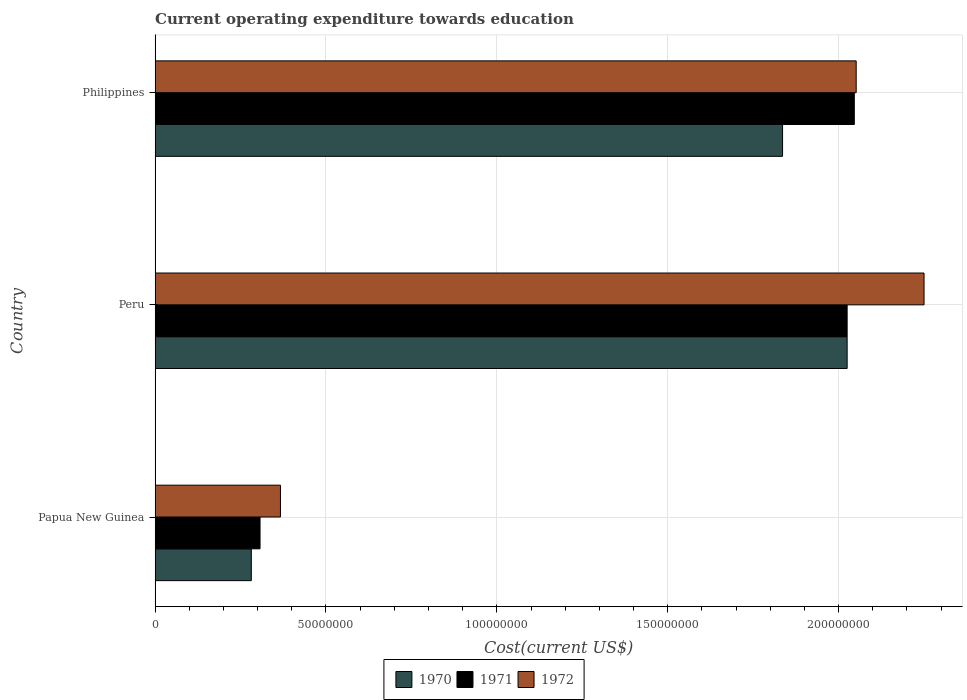How many different coloured bars are there?
Keep it short and to the point. 3. Are the number of bars per tick equal to the number of legend labels?
Provide a succinct answer. Yes. Are the number of bars on each tick of the Y-axis equal?
Your response must be concise. Yes. How many bars are there on the 2nd tick from the top?
Give a very brief answer. 3. What is the label of the 3rd group of bars from the top?
Your answer should be compact. Papua New Guinea. What is the expenditure towards education in 1971 in Peru?
Provide a short and direct response. 2.02e+08. Across all countries, what is the maximum expenditure towards education in 1970?
Ensure brevity in your answer.  2.02e+08. Across all countries, what is the minimum expenditure towards education in 1972?
Your answer should be compact. 3.67e+07. In which country was the expenditure towards education in 1971 maximum?
Your answer should be very brief. Philippines. In which country was the expenditure towards education in 1970 minimum?
Offer a very short reply. Papua New Guinea. What is the total expenditure towards education in 1972 in the graph?
Your answer should be very brief. 4.67e+08. What is the difference between the expenditure towards education in 1971 in Peru and that in Philippines?
Provide a short and direct response. -2.10e+06. What is the difference between the expenditure towards education in 1972 in Peru and the expenditure towards education in 1971 in Philippines?
Provide a succinct answer. 2.04e+07. What is the average expenditure towards education in 1972 per country?
Keep it short and to the point. 1.56e+08. What is the difference between the expenditure towards education in 1972 and expenditure towards education in 1971 in Papua New Guinea?
Your answer should be very brief. 5.97e+06. In how many countries, is the expenditure towards education in 1971 greater than 70000000 US$?
Keep it short and to the point. 2. What is the ratio of the expenditure towards education in 1970 in Papua New Guinea to that in Peru?
Provide a succinct answer. 0.14. Is the difference between the expenditure towards education in 1972 in Peru and Philippines greater than the difference between the expenditure towards education in 1971 in Peru and Philippines?
Your answer should be very brief. Yes. What is the difference between the highest and the second highest expenditure towards education in 1971?
Provide a succinct answer. 2.10e+06. What is the difference between the highest and the lowest expenditure towards education in 1970?
Provide a succinct answer. 1.74e+08. How many countries are there in the graph?
Offer a very short reply. 3. What is the difference between two consecutive major ticks on the X-axis?
Offer a terse response. 5.00e+07. Does the graph contain any zero values?
Make the answer very short. No. Does the graph contain grids?
Provide a succinct answer. Yes. Where does the legend appear in the graph?
Keep it short and to the point. Bottom center. What is the title of the graph?
Your answer should be compact. Current operating expenditure towards education. What is the label or title of the X-axis?
Keep it short and to the point. Cost(current US$). What is the label or title of the Y-axis?
Provide a succinct answer. Country. What is the Cost(current US$) of 1970 in Papua New Guinea?
Your answer should be very brief. 2.82e+07. What is the Cost(current US$) of 1971 in Papua New Guinea?
Provide a short and direct response. 3.07e+07. What is the Cost(current US$) of 1972 in Papua New Guinea?
Give a very brief answer. 3.67e+07. What is the Cost(current US$) in 1970 in Peru?
Keep it short and to the point. 2.02e+08. What is the Cost(current US$) in 1971 in Peru?
Your response must be concise. 2.02e+08. What is the Cost(current US$) in 1972 in Peru?
Provide a succinct answer. 2.25e+08. What is the Cost(current US$) of 1970 in Philippines?
Offer a terse response. 1.84e+08. What is the Cost(current US$) in 1971 in Philippines?
Make the answer very short. 2.05e+08. What is the Cost(current US$) in 1972 in Philippines?
Your answer should be compact. 2.05e+08. Across all countries, what is the maximum Cost(current US$) in 1970?
Give a very brief answer. 2.02e+08. Across all countries, what is the maximum Cost(current US$) of 1971?
Your answer should be compact. 2.05e+08. Across all countries, what is the maximum Cost(current US$) of 1972?
Keep it short and to the point. 2.25e+08. Across all countries, what is the minimum Cost(current US$) of 1970?
Make the answer very short. 2.82e+07. Across all countries, what is the minimum Cost(current US$) in 1971?
Keep it short and to the point. 3.07e+07. Across all countries, what is the minimum Cost(current US$) in 1972?
Provide a succinct answer. 3.67e+07. What is the total Cost(current US$) of 1970 in the graph?
Provide a short and direct response. 4.14e+08. What is the total Cost(current US$) in 1971 in the graph?
Provide a short and direct response. 4.38e+08. What is the total Cost(current US$) of 1972 in the graph?
Offer a terse response. 4.67e+08. What is the difference between the Cost(current US$) of 1970 in Papua New Guinea and that in Peru?
Ensure brevity in your answer.  -1.74e+08. What is the difference between the Cost(current US$) in 1971 in Papua New Guinea and that in Peru?
Keep it short and to the point. -1.72e+08. What is the difference between the Cost(current US$) of 1972 in Papua New Guinea and that in Peru?
Provide a succinct answer. -1.88e+08. What is the difference between the Cost(current US$) in 1970 in Papua New Guinea and that in Philippines?
Keep it short and to the point. -1.55e+08. What is the difference between the Cost(current US$) in 1971 in Papua New Guinea and that in Philippines?
Make the answer very short. -1.74e+08. What is the difference between the Cost(current US$) in 1972 in Papua New Guinea and that in Philippines?
Offer a very short reply. -1.68e+08. What is the difference between the Cost(current US$) of 1970 in Peru and that in Philippines?
Keep it short and to the point. 1.89e+07. What is the difference between the Cost(current US$) in 1971 in Peru and that in Philippines?
Your answer should be compact. -2.10e+06. What is the difference between the Cost(current US$) in 1972 in Peru and that in Philippines?
Provide a succinct answer. 1.99e+07. What is the difference between the Cost(current US$) in 1970 in Papua New Guinea and the Cost(current US$) in 1971 in Peru?
Offer a terse response. -1.74e+08. What is the difference between the Cost(current US$) of 1970 in Papua New Guinea and the Cost(current US$) of 1972 in Peru?
Make the answer very short. -1.97e+08. What is the difference between the Cost(current US$) in 1971 in Papua New Guinea and the Cost(current US$) in 1972 in Peru?
Your answer should be compact. -1.94e+08. What is the difference between the Cost(current US$) in 1970 in Papua New Guinea and the Cost(current US$) in 1971 in Philippines?
Provide a short and direct response. -1.76e+08. What is the difference between the Cost(current US$) in 1970 in Papua New Guinea and the Cost(current US$) in 1972 in Philippines?
Give a very brief answer. -1.77e+08. What is the difference between the Cost(current US$) of 1971 in Papua New Guinea and the Cost(current US$) of 1972 in Philippines?
Keep it short and to the point. -1.74e+08. What is the difference between the Cost(current US$) in 1970 in Peru and the Cost(current US$) in 1971 in Philippines?
Your answer should be very brief. -2.10e+06. What is the difference between the Cost(current US$) in 1970 in Peru and the Cost(current US$) in 1972 in Philippines?
Offer a terse response. -2.64e+06. What is the difference between the Cost(current US$) in 1971 in Peru and the Cost(current US$) in 1972 in Philippines?
Your answer should be very brief. -2.64e+06. What is the average Cost(current US$) of 1970 per country?
Provide a short and direct response. 1.38e+08. What is the average Cost(current US$) of 1971 per country?
Provide a succinct answer. 1.46e+08. What is the average Cost(current US$) of 1972 per country?
Give a very brief answer. 1.56e+08. What is the difference between the Cost(current US$) of 1970 and Cost(current US$) of 1971 in Papua New Guinea?
Your answer should be compact. -2.55e+06. What is the difference between the Cost(current US$) in 1970 and Cost(current US$) in 1972 in Papua New Guinea?
Your response must be concise. -8.53e+06. What is the difference between the Cost(current US$) in 1971 and Cost(current US$) in 1972 in Papua New Guinea?
Provide a short and direct response. -5.97e+06. What is the difference between the Cost(current US$) of 1970 and Cost(current US$) of 1971 in Peru?
Your answer should be very brief. 0. What is the difference between the Cost(current US$) in 1970 and Cost(current US$) in 1972 in Peru?
Provide a succinct answer. -2.25e+07. What is the difference between the Cost(current US$) of 1971 and Cost(current US$) of 1972 in Peru?
Keep it short and to the point. -2.25e+07. What is the difference between the Cost(current US$) of 1970 and Cost(current US$) of 1971 in Philippines?
Your response must be concise. -2.10e+07. What is the difference between the Cost(current US$) in 1970 and Cost(current US$) in 1972 in Philippines?
Your answer should be very brief. -2.15e+07. What is the difference between the Cost(current US$) in 1971 and Cost(current US$) in 1972 in Philippines?
Your answer should be compact. -5.49e+05. What is the ratio of the Cost(current US$) of 1970 in Papua New Guinea to that in Peru?
Provide a short and direct response. 0.14. What is the ratio of the Cost(current US$) in 1971 in Papua New Guinea to that in Peru?
Your answer should be very brief. 0.15. What is the ratio of the Cost(current US$) of 1972 in Papua New Guinea to that in Peru?
Your response must be concise. 0.16. What is the ratio of the Cost(current US$) in 1970 in Papua New Guinea to that in Philippines?
Provide a short and direct response. 0.15. What is the ratio of the Cost(current US$) in 1971 in Papua New Guinea to that in Philippines?
Ensure brevity in your answer.  0.15. What is the ratio of the Cost(current US$) of 1972 in Papua New Guinea to that in Philippines?
Give a very brief answer. 0.18. What is the ratio of the Cost(current US$) in 1970 in Peru to that in Philippines?
Your answer should be very brief. 1.1. What is the ratio of the Cost(current US$) in 1972 in Peru to that in Philippines?
Ensure brevity in your answer.  1.1. What is the difference between the highest and the second highest Cost(current US$) in 1970?
Your answer should be compact. 1.89e+07. What is the difference between the highest and the second highest Cost(current US$) in 1971?
Offer a very short reply. 2.10e+06. What is the difference between the highest and the second highest Cost(current US$) of 1972?
Ensure brevity in your answer.  1.99e+07. What is the difference between the highest and the lowest Cost(current US$) in 1970?
Offer a very short reply. 1.74e+08. What is the difference between the highest and the lowest Cost(current US$) of 1971?
Make the answer very short. 1.74e+08. What is the difference between the highest and the lowest Cost(current US$) of 1972?
Ensure brevity in your answer.  1.88e+08. 